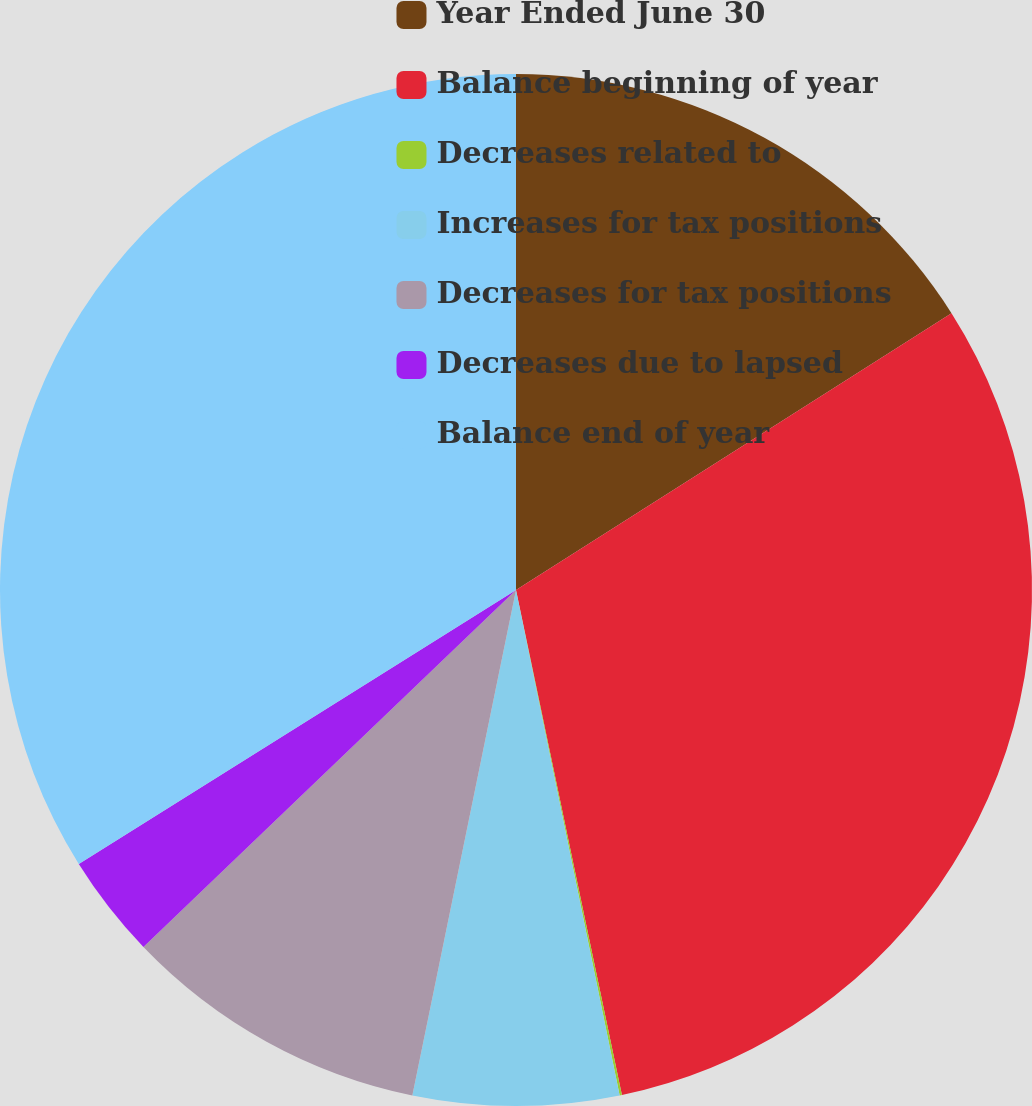Convert chart to OTSL. <chart><loc_0><loc_0><loc_500><loc_500><pie_chart><fcel>Year Ended June 30<fcel>Balance beginning of year<fcel>Decreases related to<fcel>Increases for tax positions<fcel>Decreases for tax positions<fcel>Decreases due to lapsed<fcel>Balance end of year<nl><fcel>15.99%<fcel>30.72%<fcel>0.07%<fcel>6.44%<fcel>9.62%<fcel>3.25%<fcel>33.91%<nl></chart> 